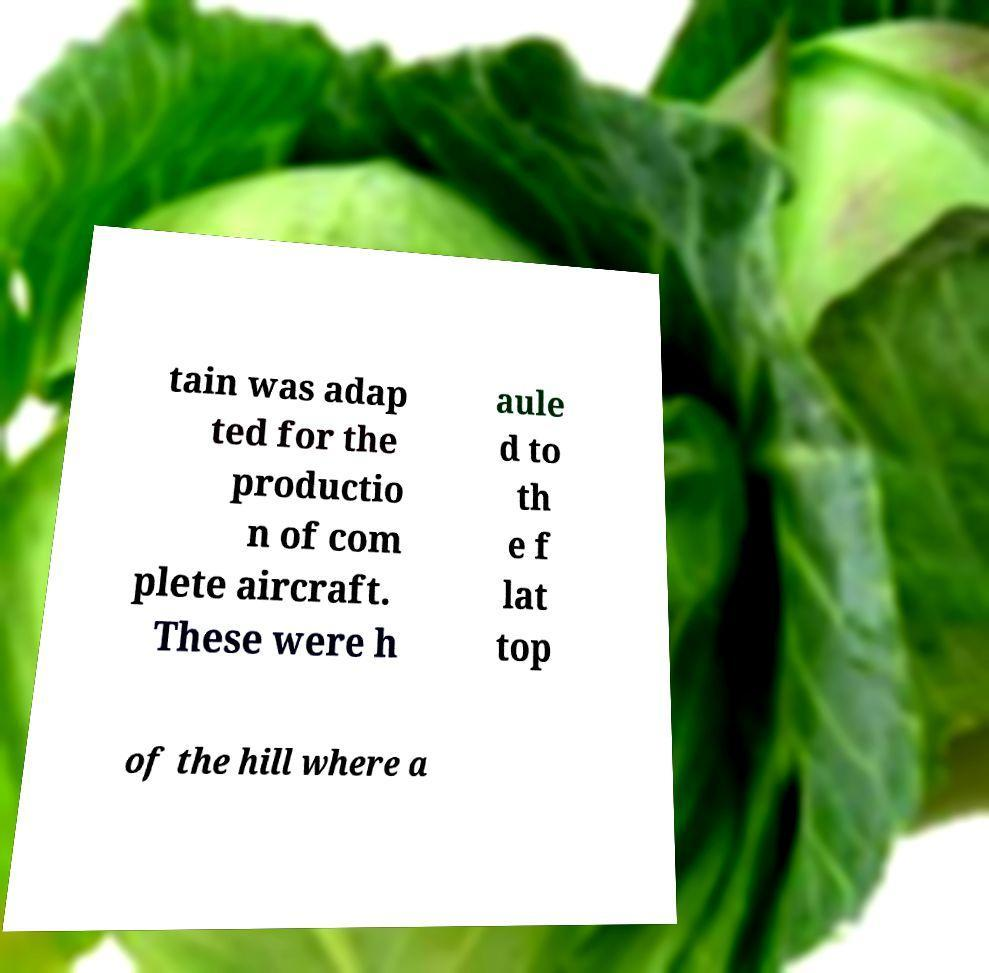There's text embedded in this image that I need extracted. Can you transcribe it verbatim? tain was adap ted for the productio n of com plete aircraft. These were h aule d to th e f lat top of the hill where a 